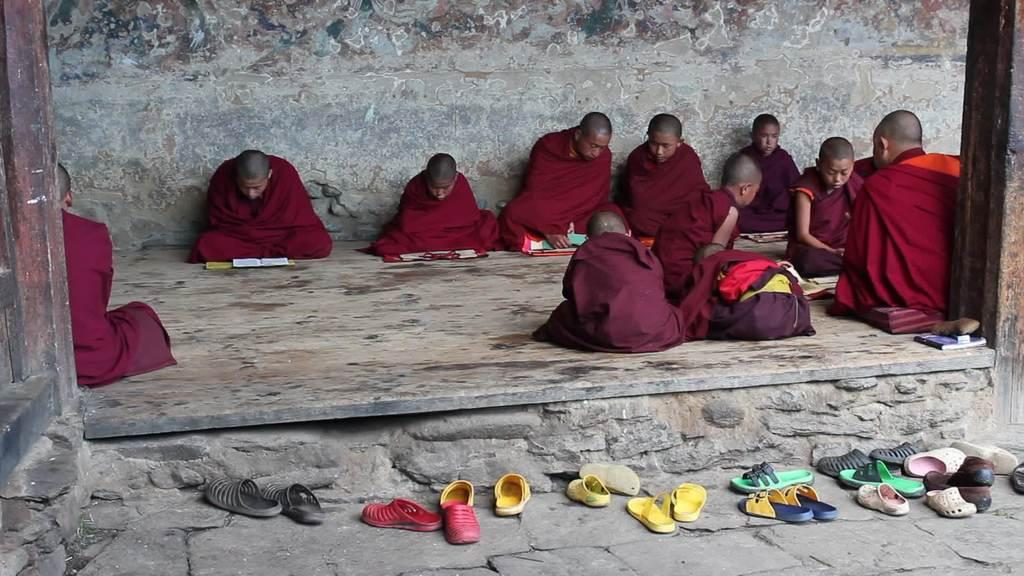What type of people can be seen in the image? There are many Buddhist monks in the image. What are the monks sitting on? The monks are sitting on a wooden floor. What activity are the monks engaged in? The monks are reading books. What can be seen on the floor in the front of the image? There are many footwear on the floor in the front of the image. Are there any sticks or tails visible in the image? No, there are no sticks or tails present in the image. Is there a squirrel interacting with the monks in the image? No, there is no squirrel present in the image. 